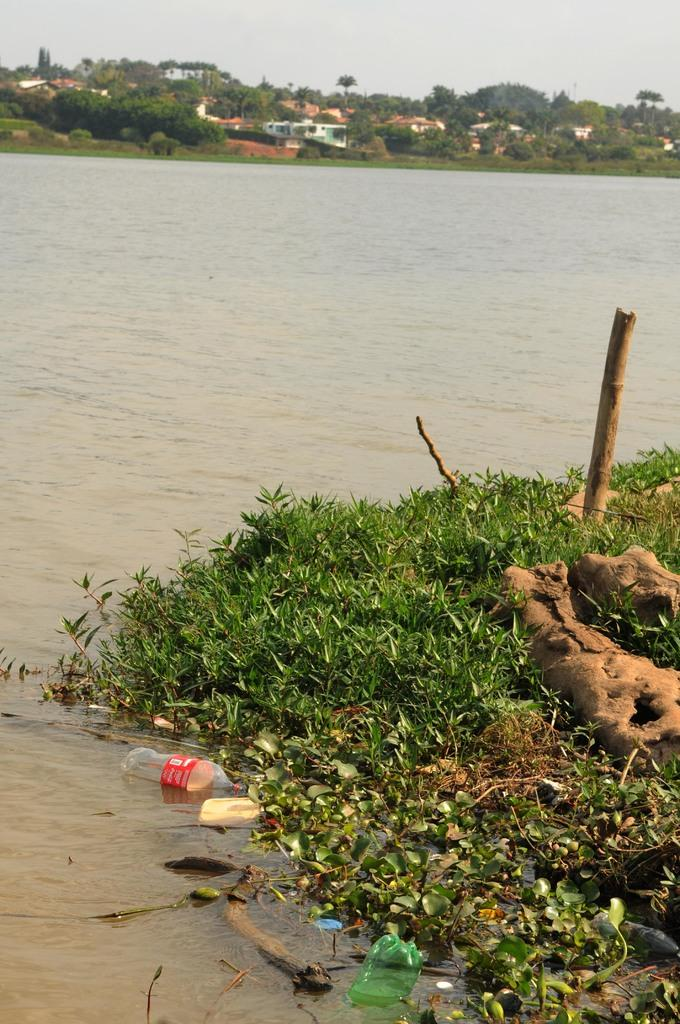What type of vegetation is present on the land in the image? There is grass on the land in the image. What body of water is visible in the image? There is a river in the image. What type of litter can be seen in the water? There are plastic bottles in the water. What can be seen in the background of the image? There are trees and houses in the background of the image. What is visible in the sky in the image? The sky is visible in the background of the image. How many times does the grandmother roll down the hill in the image? There is no grandmother or rolling down a hill depicted in the image. What type of waste is present in the image? The only waste mentioned in the image is the plastic bottles in the water, but they are not referred to as "waste" in the facts provided. 